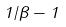<formula> <loc_0><loc_0><loc_500><loc_500>1 / \beta - 1</formula> 